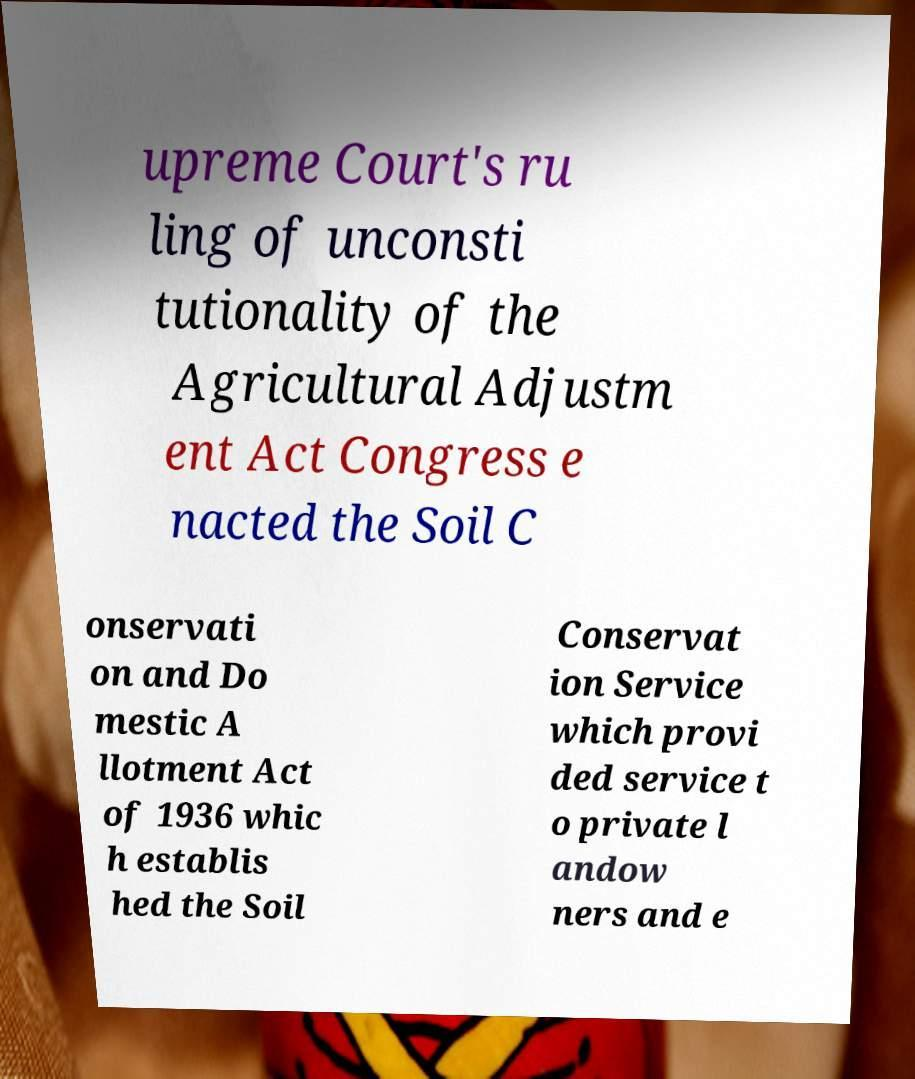Can you accurately transcribe the text from the provided image for me? upreme Court's ru ling of unconsti tutionality of the Agricultural Adjustm ent Act Congress e nacted the Soil C onservati on and Do mestic A llotment Act of 1936 whic h establis hed the Soil Conservat ion Service which provi ded service t o private l andow ners and e 